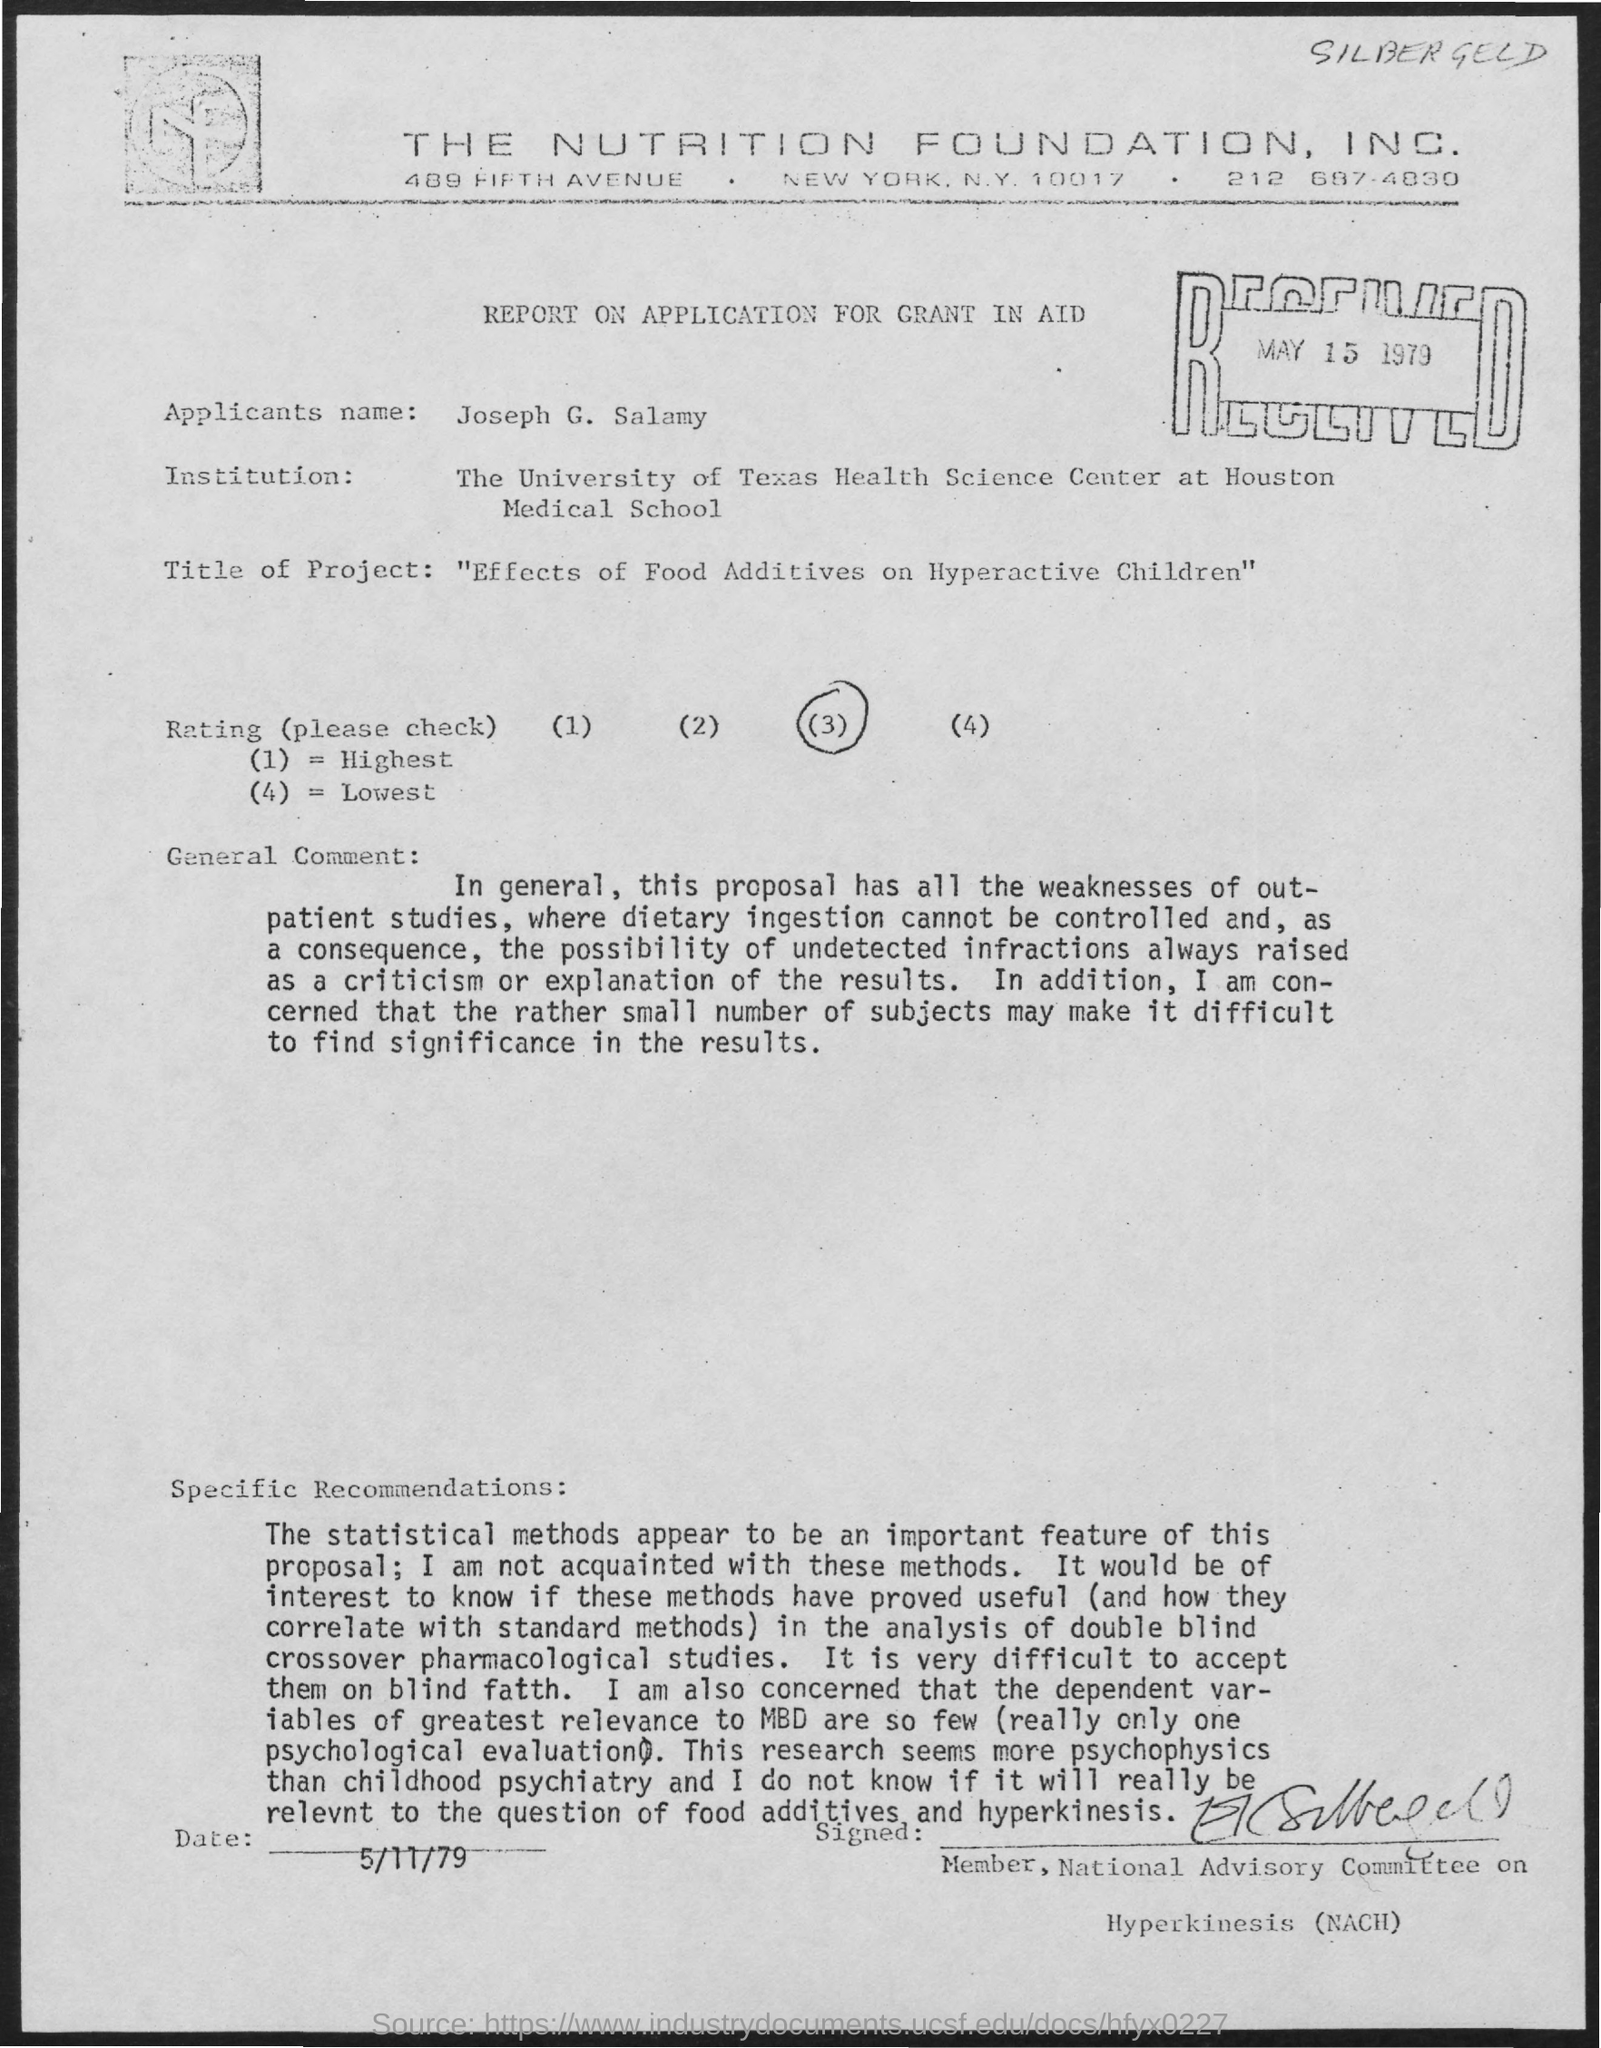Specify some key components in this picture. The Nutrition Foundation, Inc. is the name of the foundation that this document belongs to. The name of the applicant is Joseph G. Salamy. The document was received on May 15, 1979. The rating chosen in this document is (3).. 